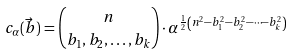Convert formula to latex. <formula><loc_0><loc_0><loc_500><loc_500>c _ { \alpha } ( \vec { b } ) = { n \choose { b _ { 1 } , b _ { 2 } , \dots , b _ { k } } } \cdot \alpha ^ { \frac { 1 } { 2 } \left ( n ^ { 2 } - b _ { 1 } ^ { 2 } - b _ { 2 } ^ { 2 } - \dots - b _ { k } ^ { 2 } \right ) }</formula> 